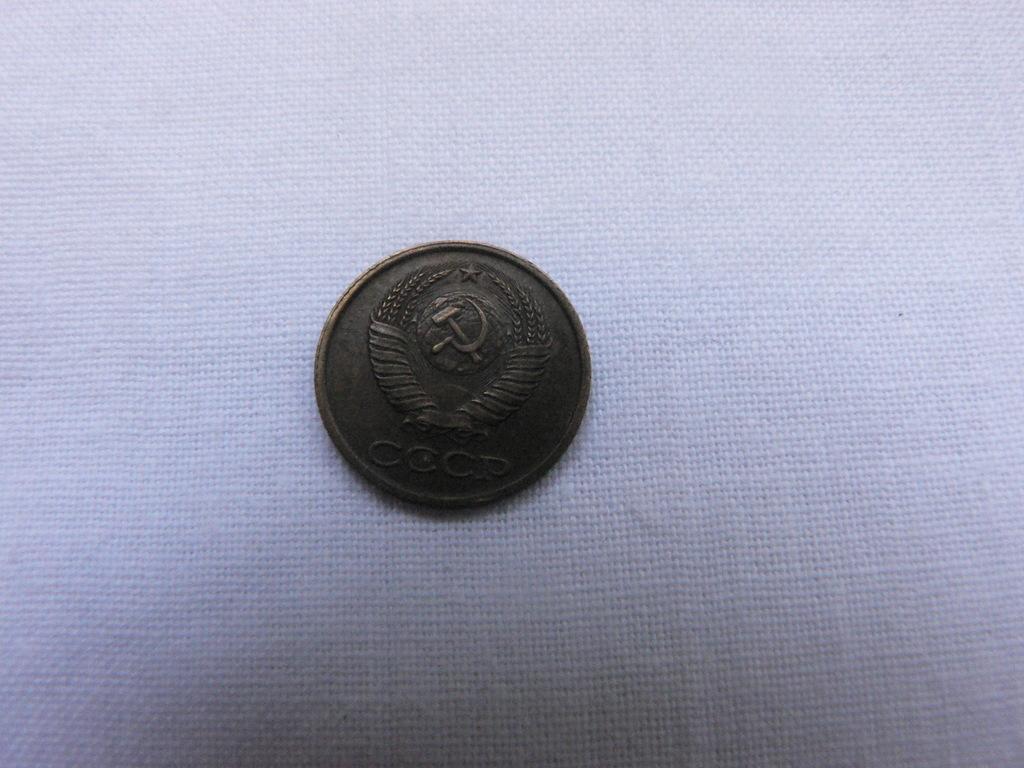In one or two sentences, can you explain what this image depicts? In the image there is some antique coin. 